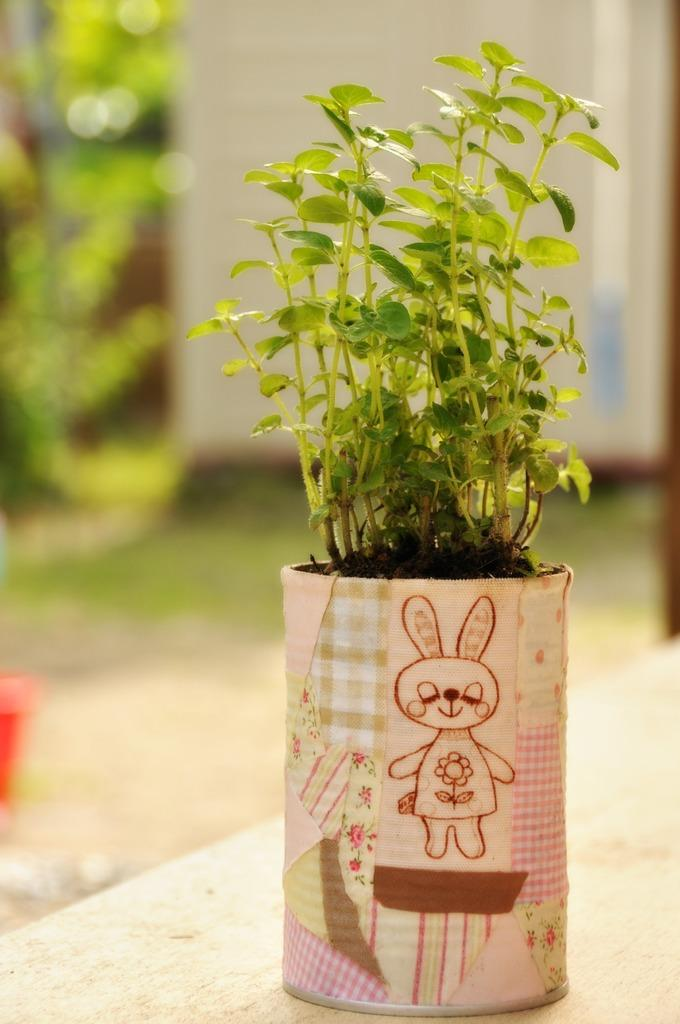What object is the main focus of the image? There is a plant pot in the image. Can you describe the background of the image? The background of the image is blurred. What type of silk is being used to create the plant pot in the image? There is no silk present in the image, as the plant pot is not made of silk. 